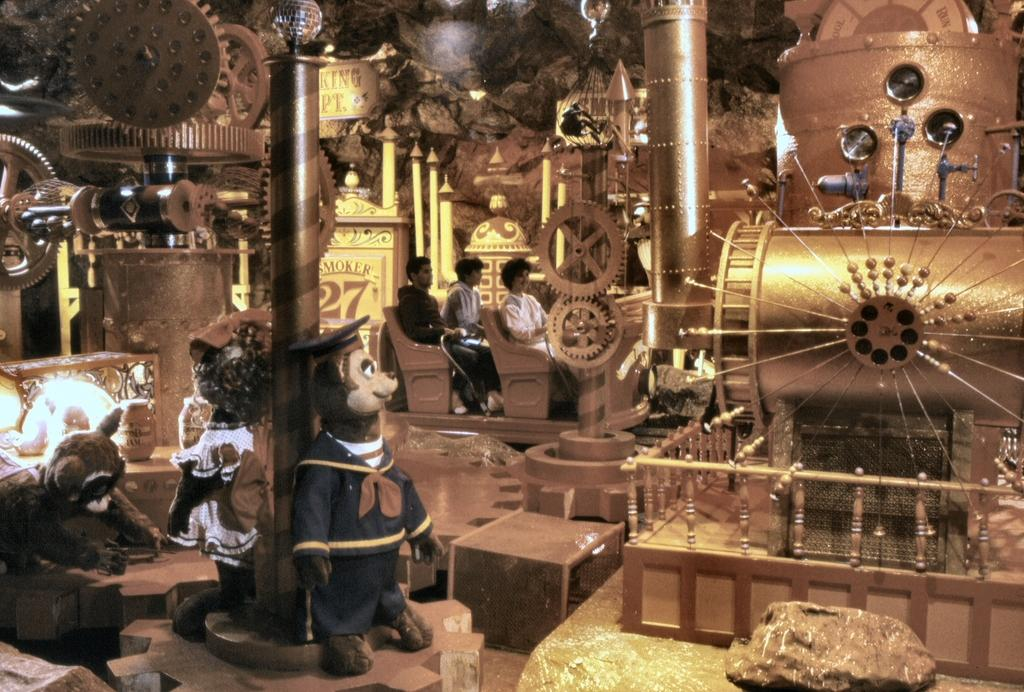What types of objects can be seen in the image? There are machines, poles, toys, boxes, and people sitting in the image. What is the terrain like in the image? The area appears to be rocky. Can you describe the people in the image? There are people sitting in the image. What color is the stream in the image? There is no stream present in the image. 